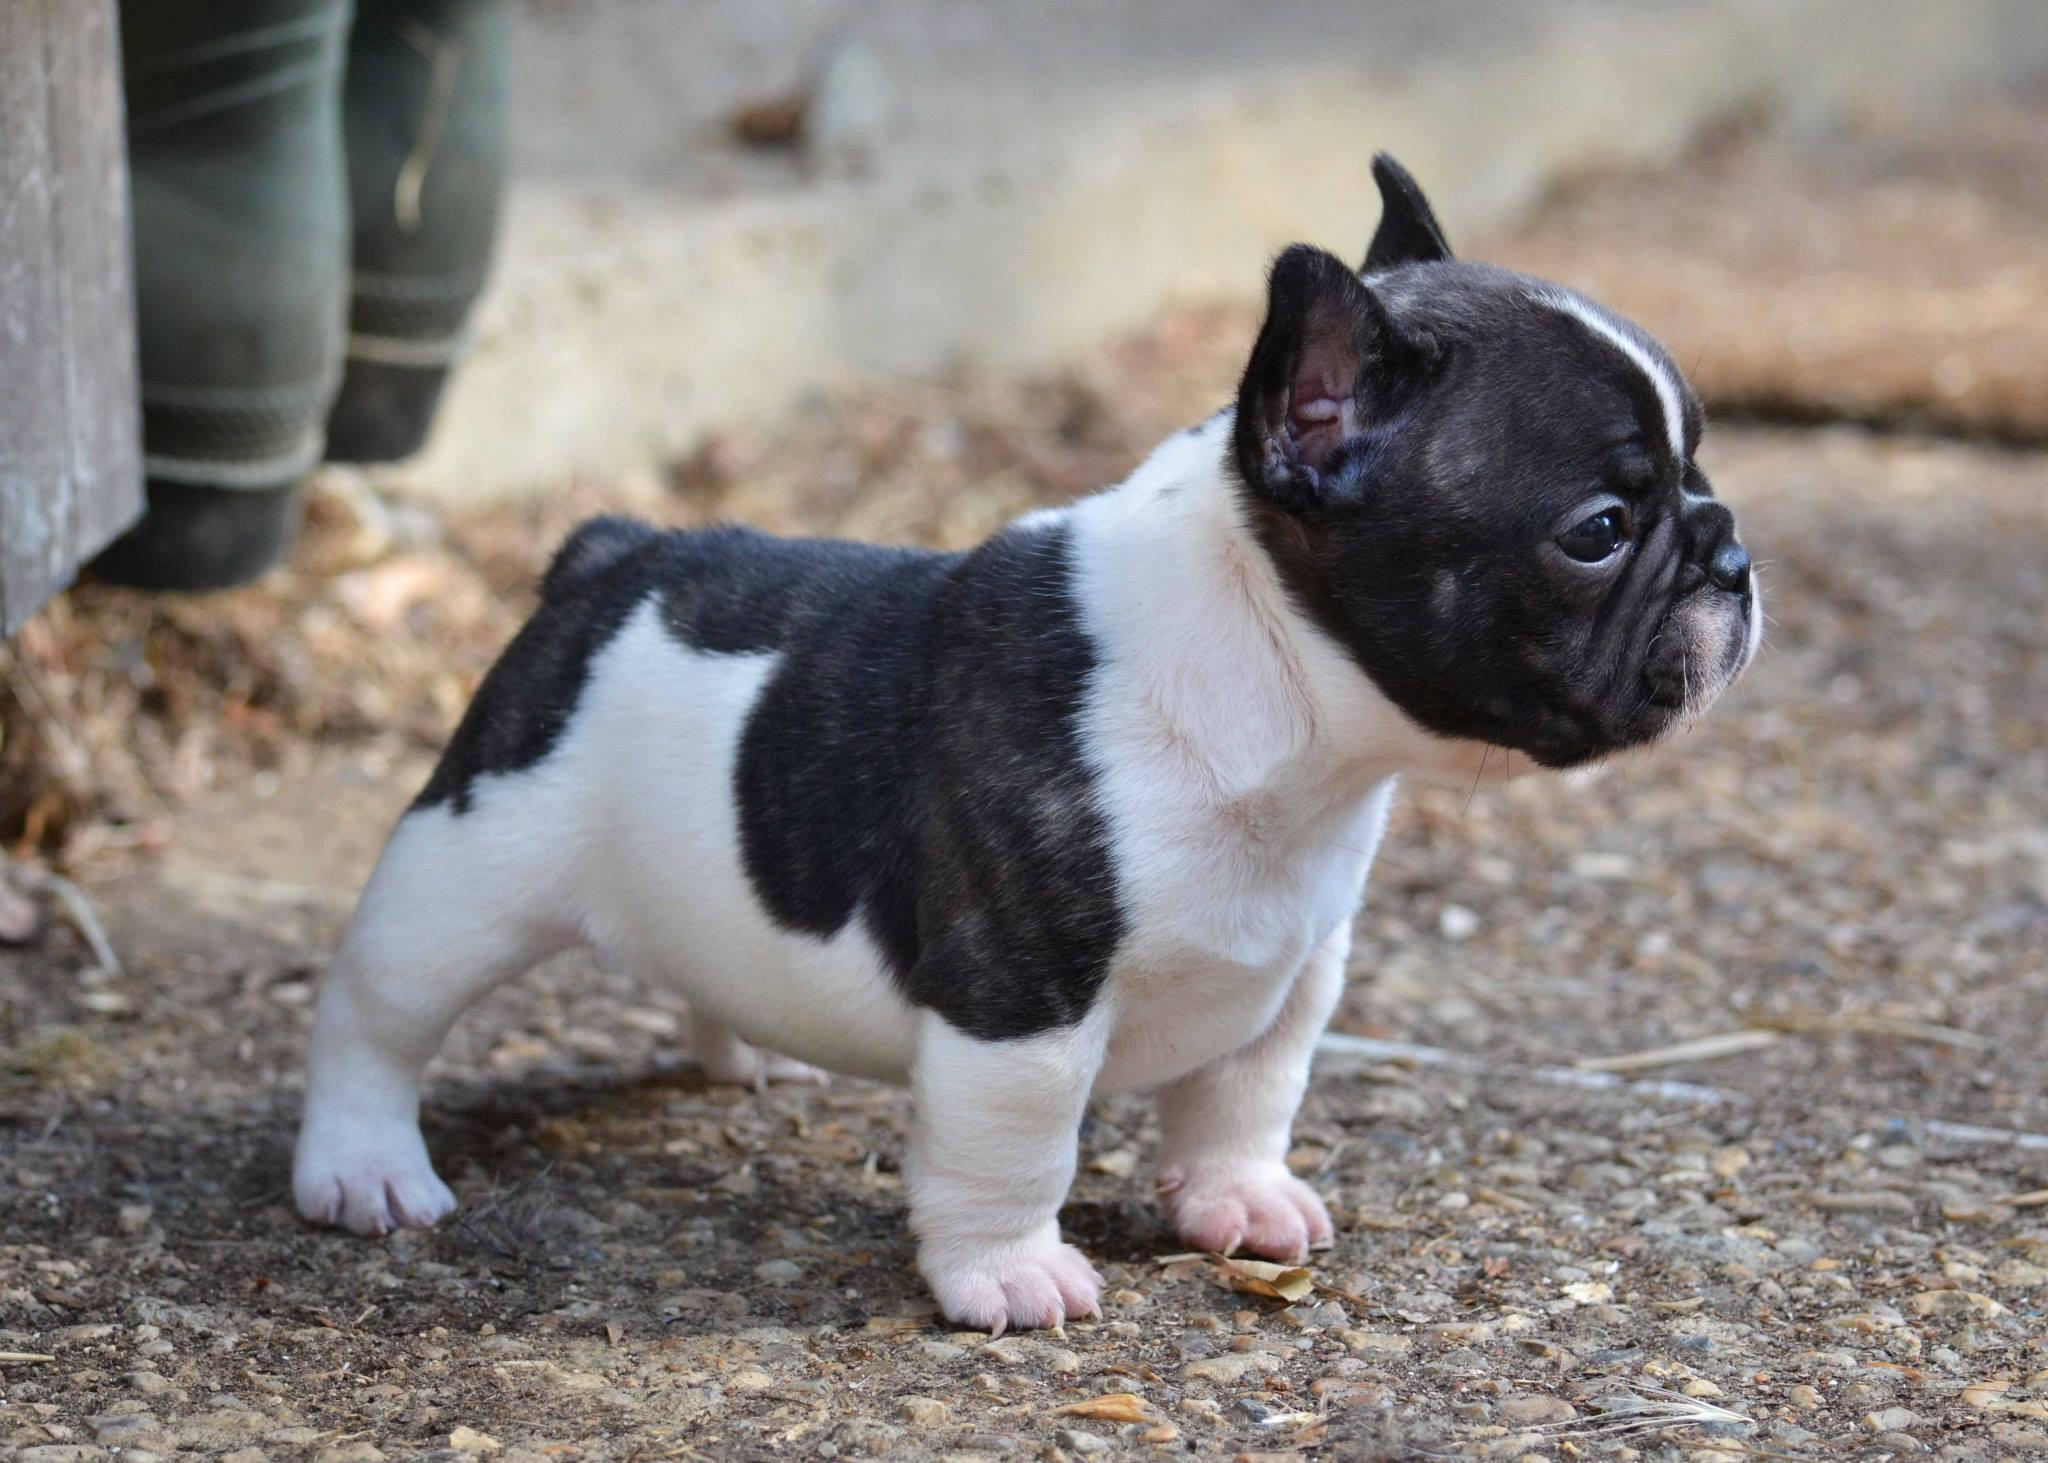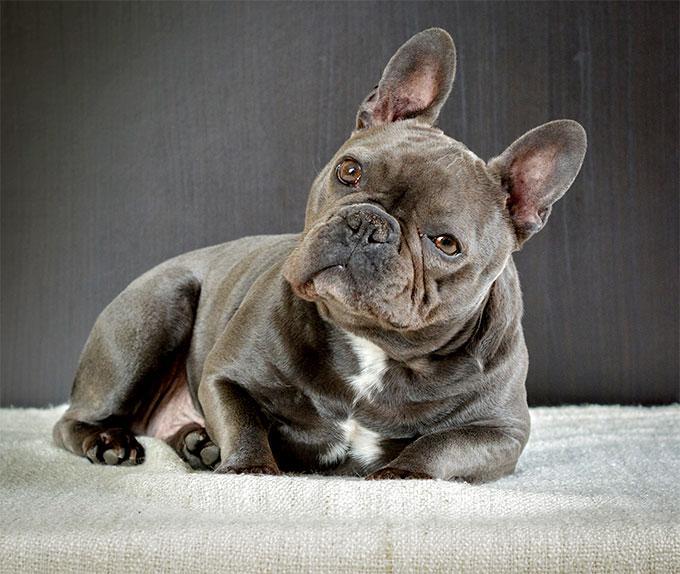The first image is the image on the left, the second image is the image on the right. Considering the images on both sides, is "An image shows one puppy standing outdoors, in profile, turned rightward." valid? Answer yes or no. Yes. The first image is the image on the left, the second image is the image on the right. Examine the images to the left and right. Is the description "One dog is standing and one is lying down, neither wearing a collar." accurate? Answer yes or no. Yes. 